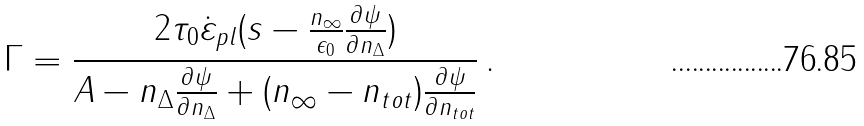<formula> <loc_0><loc_0><loc_500><loc_500>\Gamma = \frac { 2 \tau _ { 0 } \dot { \varepsilon } _ { p l } ( s - \frac { n _ { \infty } } { \epsilon _ { 0 } } \frac { \partial \psi } { \partial n _ { \Delta } } ) } { A - n _ { \Delta } \frac { \partial \psi } { \partial n _ { \Delta } } + ( n _ { \infty } - n _ { t o t } ) \frac { \partial \psi } { \partial n _ { t o t } } } \, .</formula> 